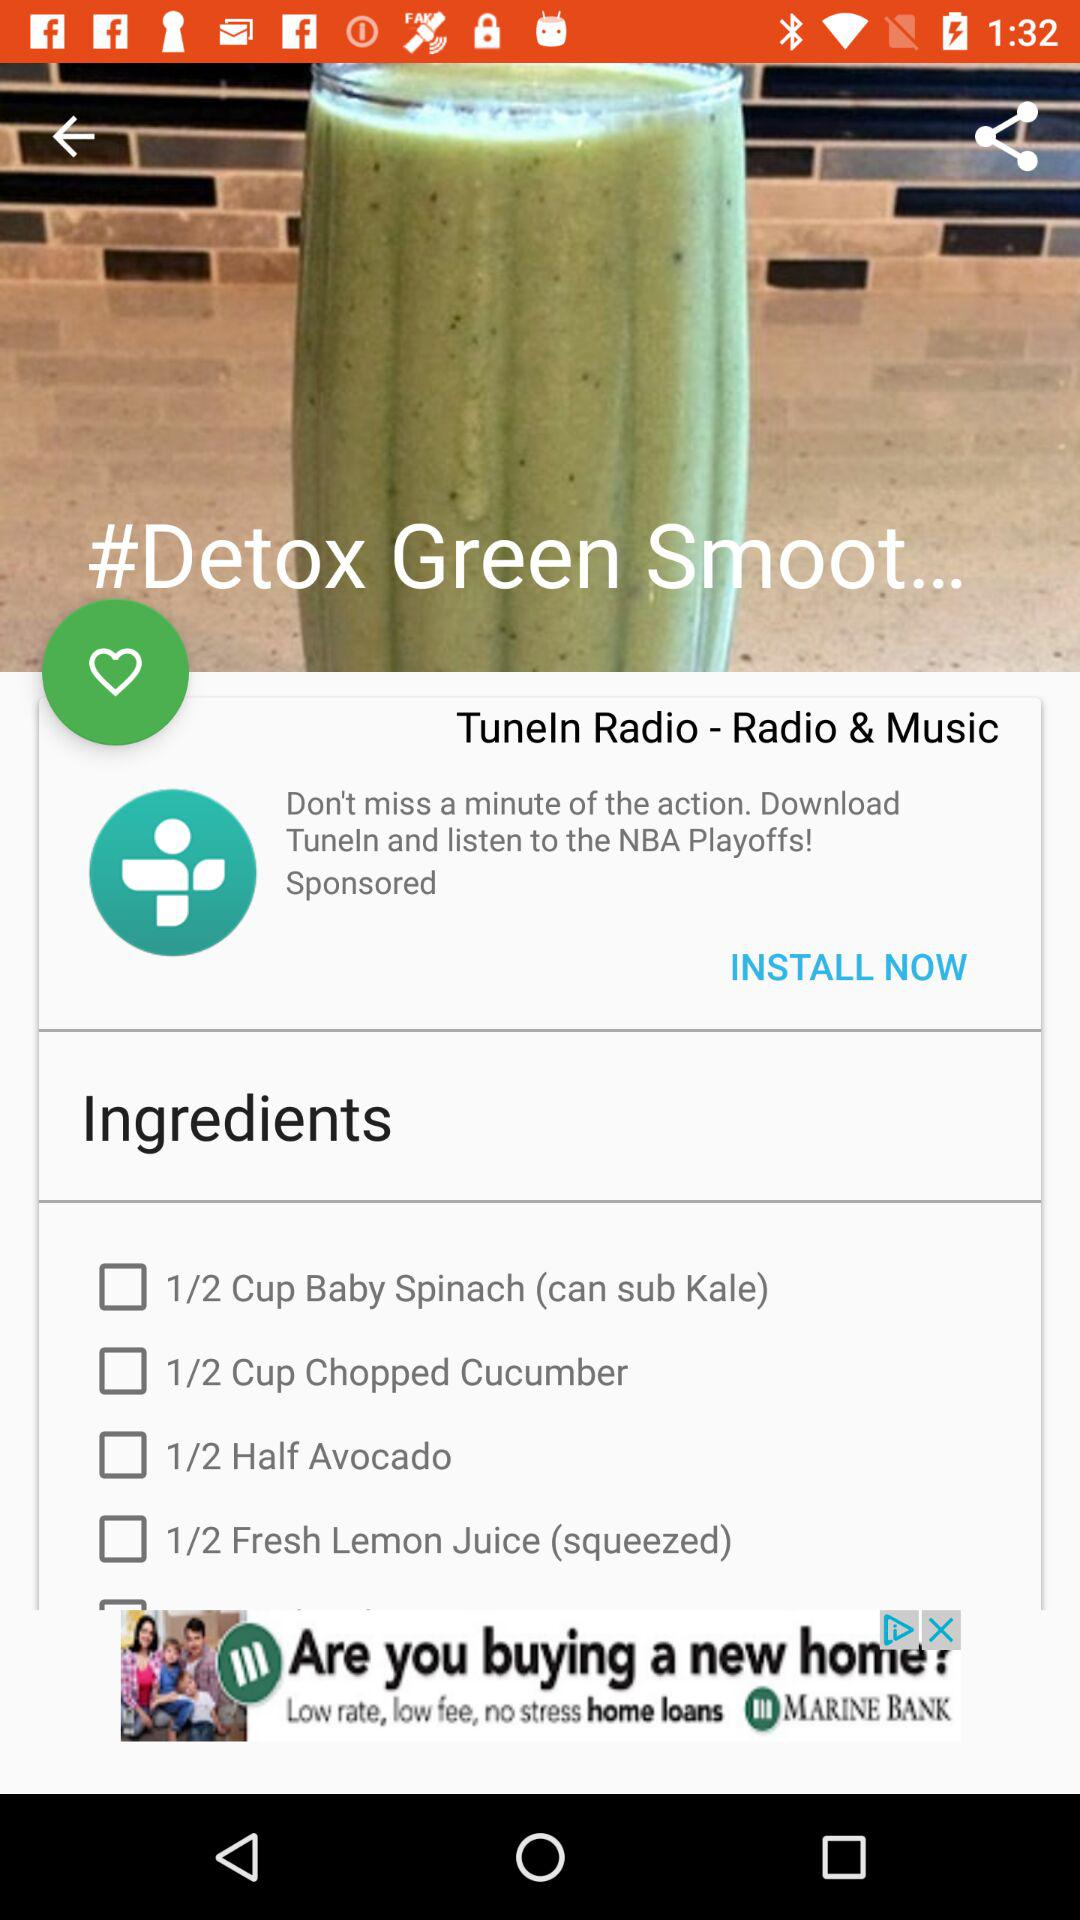How many ingredients do you need to make this smoothie?
Answer the question using a single word or phrase. 4 